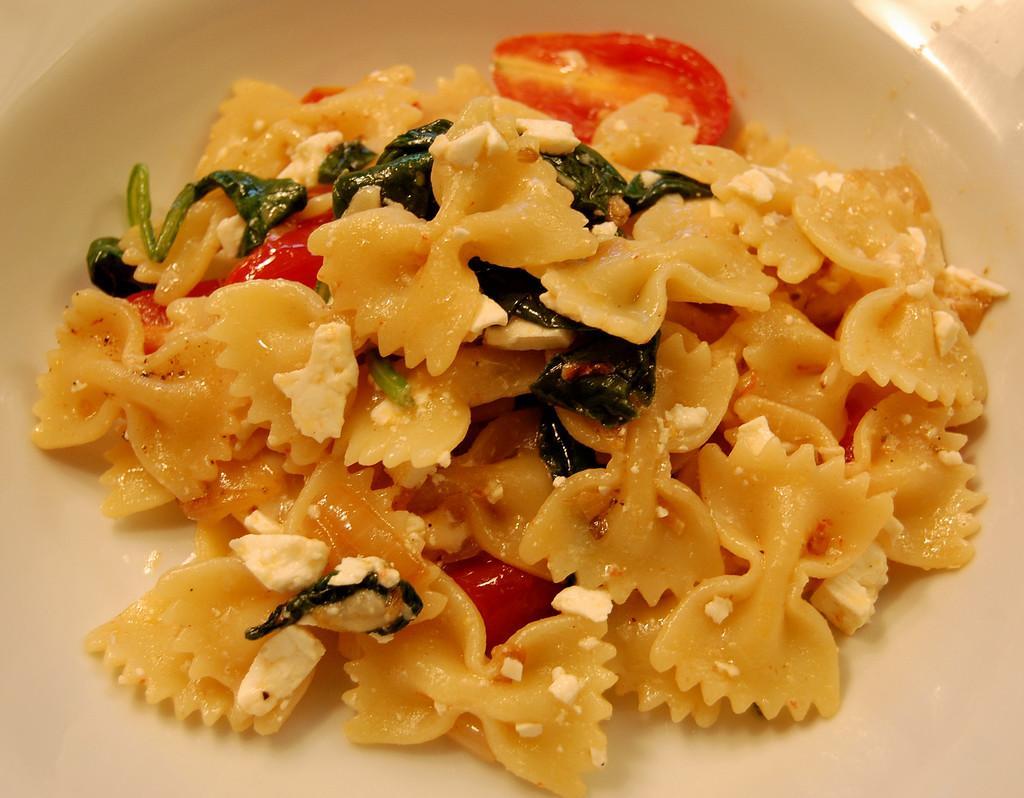How would you summarize this image in a sentence or two? In this image there is a plate, in that place there is a food item. 